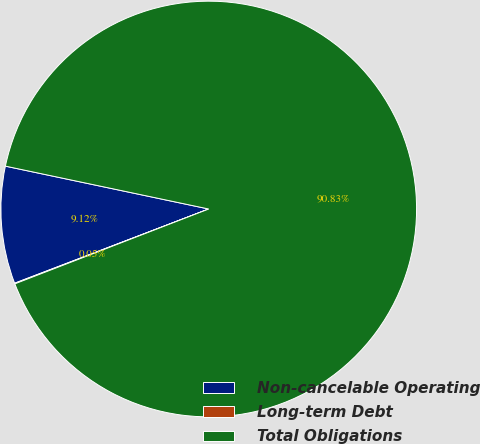<chart> <loc_0><loc_0><loc_500><loc_500><pie_chart><fcel>Non-cancelable Operating<fcel>Long-term Debt<fcel>Total Obligations<nl><fcel>9.12%<fcel>0.05%<fcel>90.83%<nl></chart> 